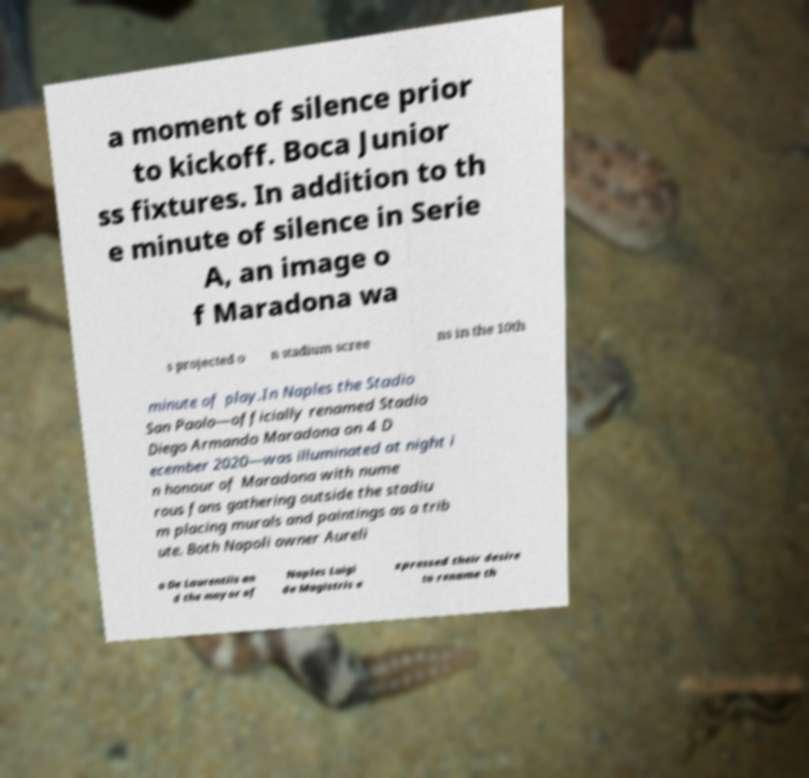Could you extract and type out the text from this image? a moment of silence prior to kickoff. Boca Junior ss fixtures. In addition to th e minute of silence in Serie A, an image o f Maradona wa s projected o n stadium scree ns in the 10th minute of play.In Naples the Stadio San Paolo—officially renamed Stadio Diego Armando Maradona on 4 D ecember 2020—was illuminated at night i n honour of Maradona with nume rous fans gathering outside the stadiu m placing murals and paintings as a trib ute. Both Napoli owner Aureli o De Laurentiis an d the mayor of Naples Luigi de Magistris e xpressed their desire to rename th 